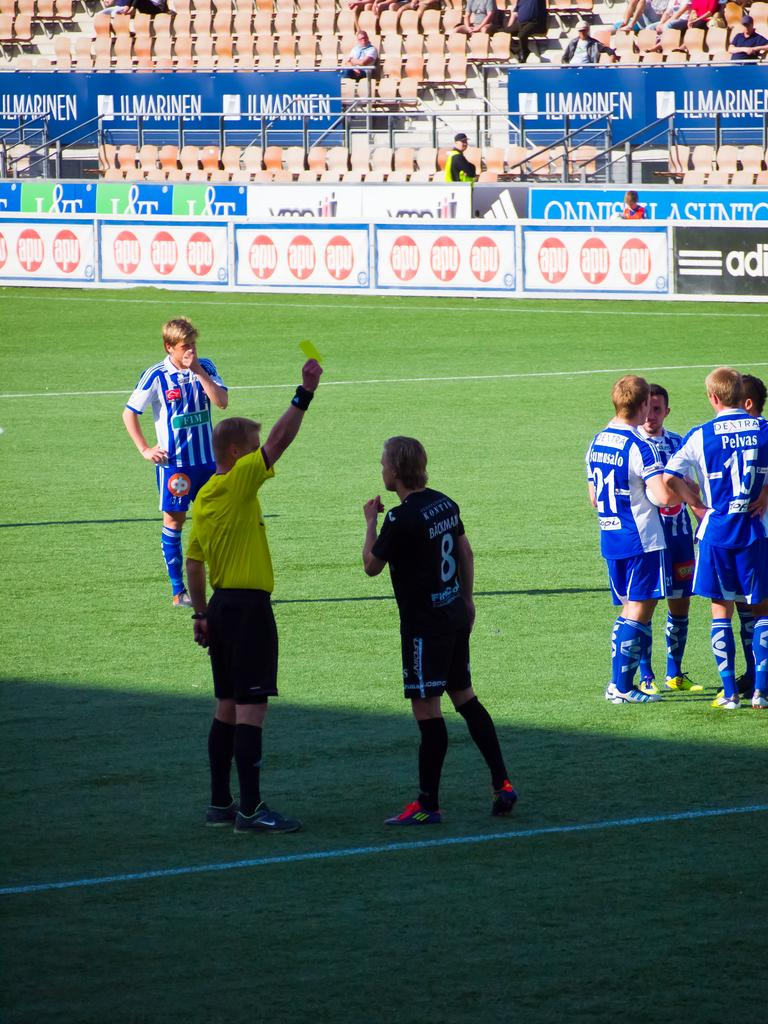What are the people in the image wearing? There is a group of people wearing blue dresses in the image. Where are the people in the image standing? The group of people is standing on the ground. Can you describe the person wearing a different color dress? There is a person wearing a black dress in the image. What is the person in the black dress doing? The person in the black dress is standing in front of a referee. What action is the referee taking in the image? The referee is showing a yellow card. What is the partner of the person in the black dress doing in the image? There is no partner present in the image for the person in the black dress. 